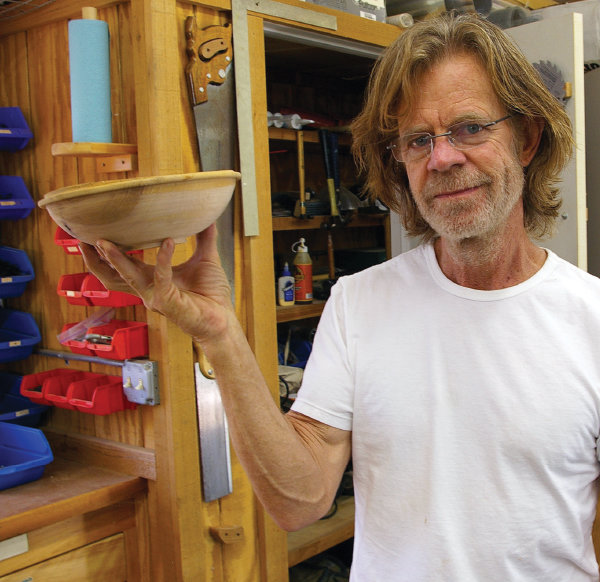What type of wood might the bowl be made from, and what are the characteristics of this wood? The bowl in the image appears to be made from a light-colored wood, possibly maple or birch. These types of wood are known for their fine grain and smooth texture, which make them excellent for crafting detailed and decorative items like bowls. Maple and birch are also relatively hard, providing durability to the crafted item. 